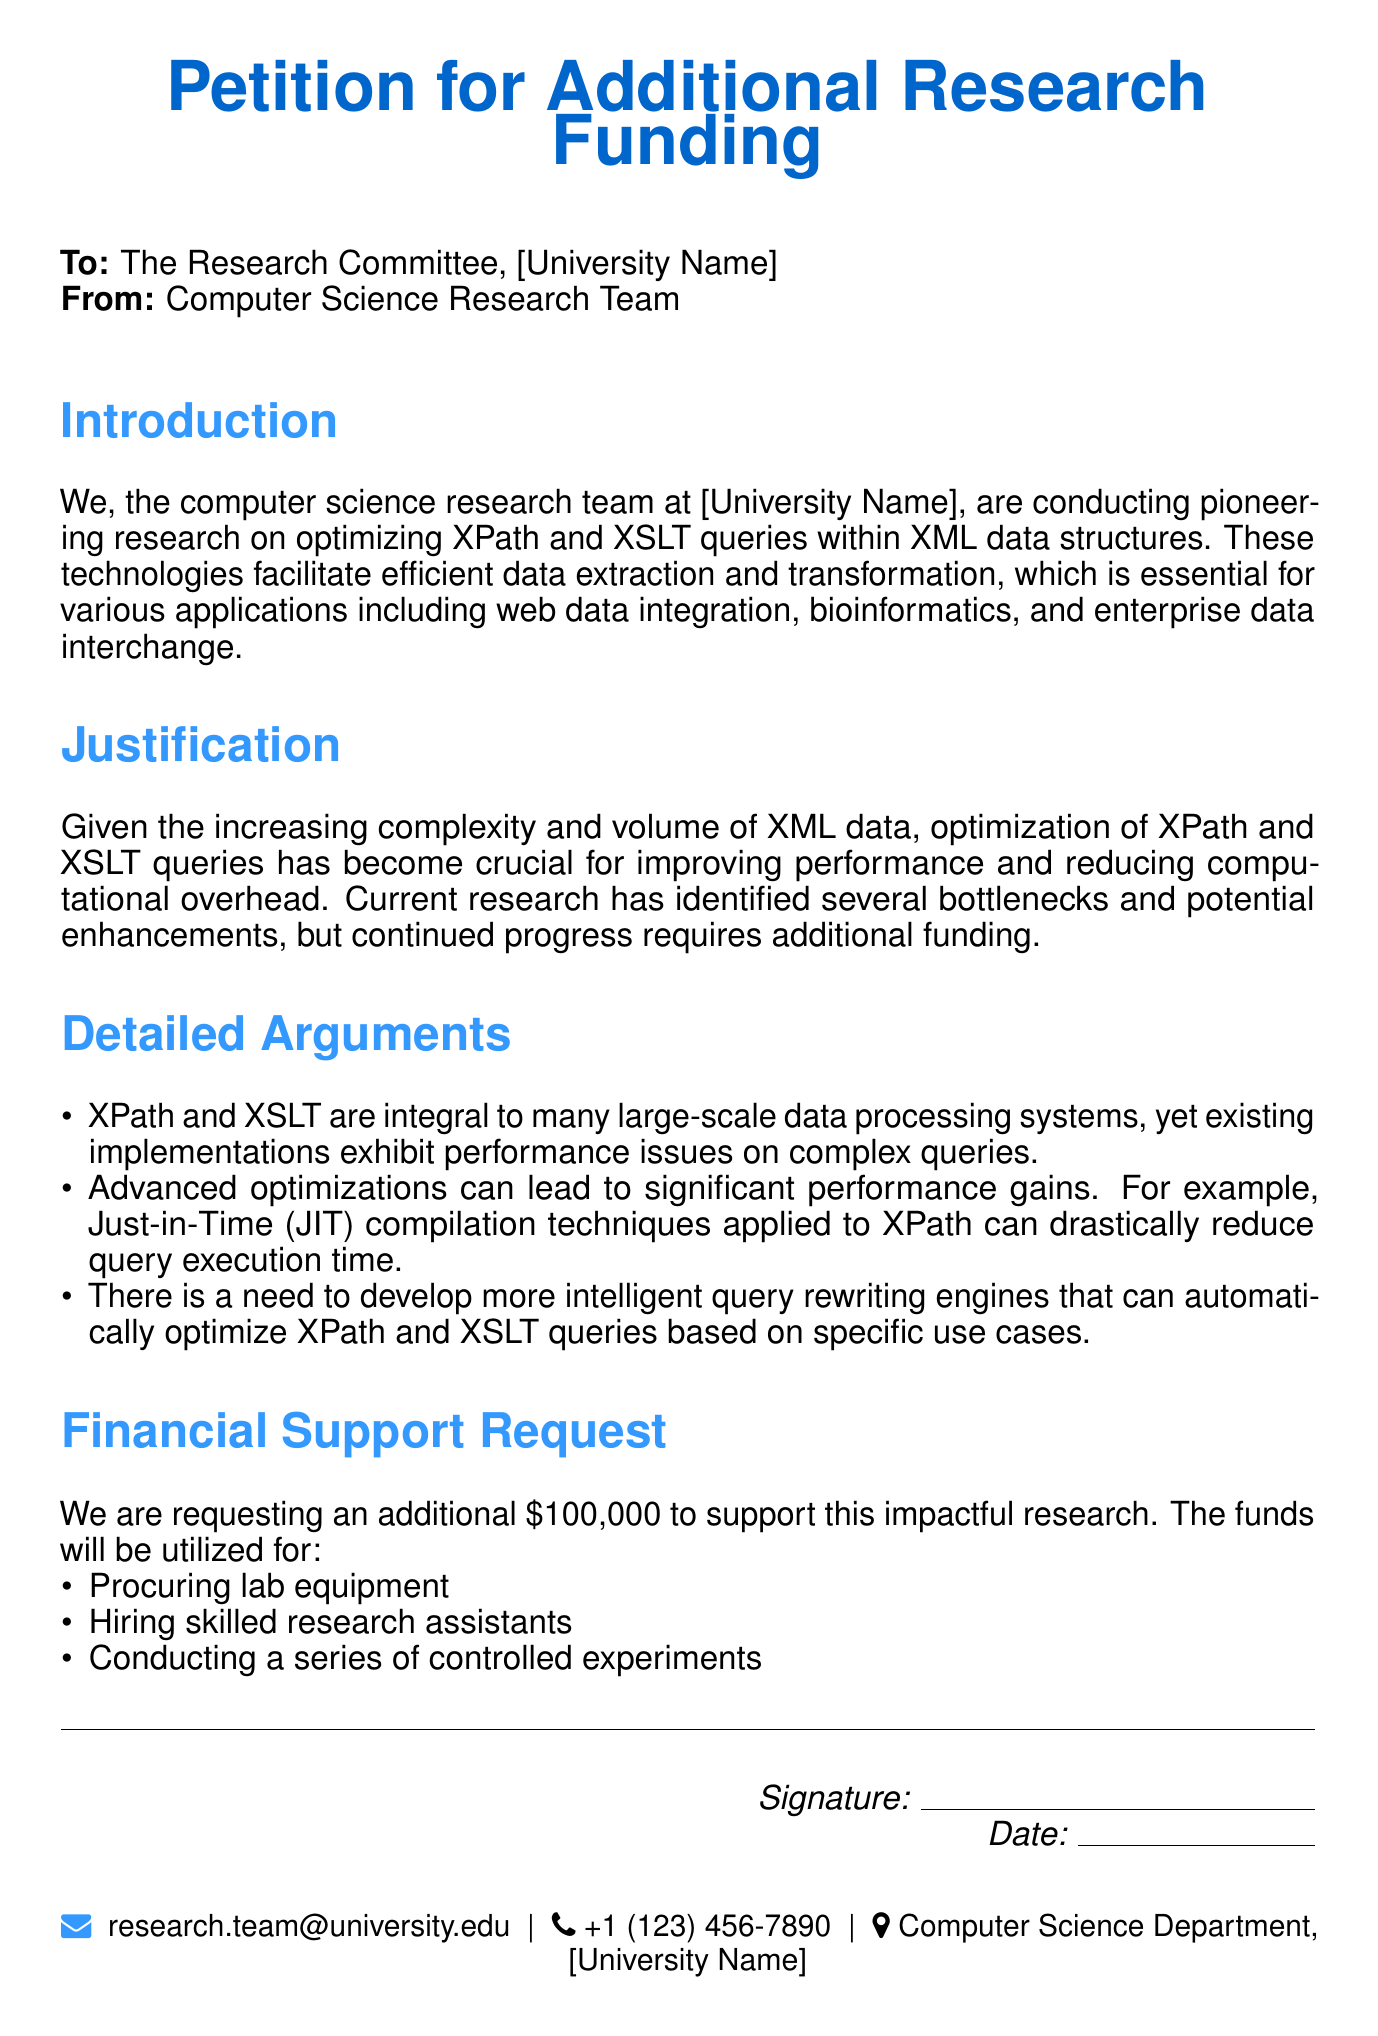What is the title of the petition? The title of the petition is the first line of the document, which states the purpose of the request for funding.
Answer: Petition for Additional Research Funding Who is the petition addressed to? The petition specifies in the second line to whom it is directed, identifying the audience for the request.
Answer: The Research Committee What is the amount of funding requested in the petition? The document mentions the exact amount of funding requested in the financial support request section.
Answer: $100,000 What is the primary focus of the research mentioned in the petition? The introduction outlines the main topic of the research being conducted, which provides context for the funding request.
Answer: Optimizing XPath and XSLT queries What is one of the reasons given for needing additional funding? The detailed arguments section lists reasons for the funding, specifically focusing on performance issues.
Answer: Performance issues on complex queries What type of experiments will the requested funds be used for? The financial support request details how the funding will be utilized, specifically mentioning the type of work that will be conducted.
Answer: Controlled experiments What is the signature line for in the document? The section at the bottom indicates that a formal acknowledgment is required, suggesting accountability for the petition.
Answer: Authorizing the petition What university department is mentioned at the end of the document? The footer includes contact details, including the department which houses the research team.
Answer: Computer Science Department 